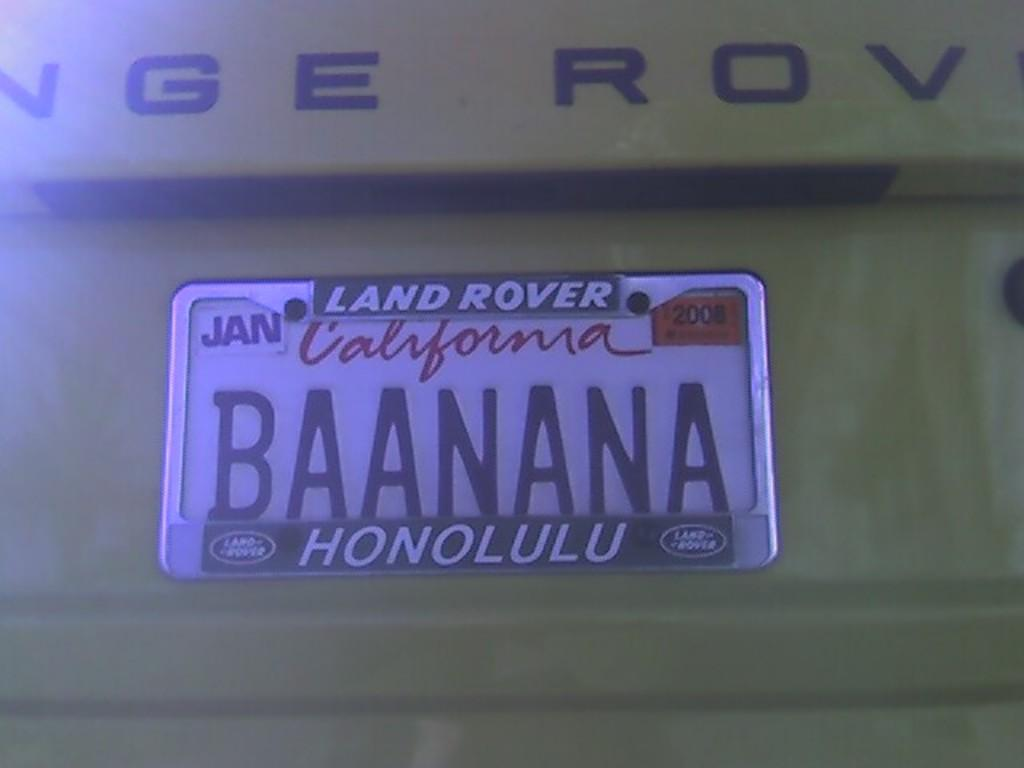<image>
Present a compact description of the photo's key features. A California license plate with the word BAANANA printed on it. 